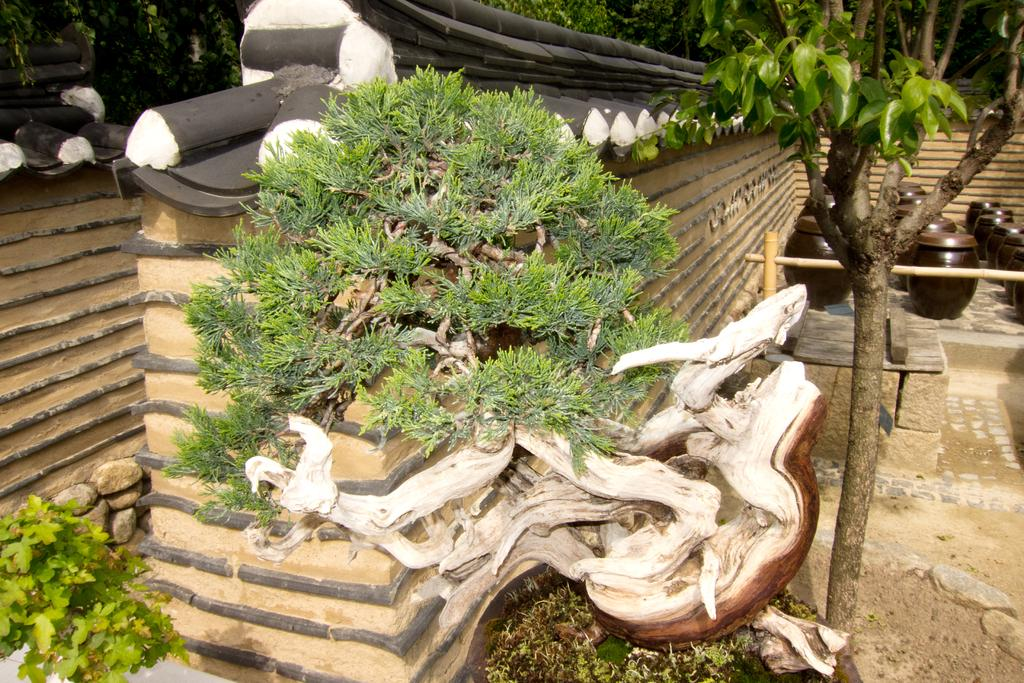What is on the wall in the image? There are plants on the wall in the image. What can be seen on the right side of the image? There are pots and a tree on the right side of the image. How many times do the plants on the wall hate each other in the image? There is no indication of emotions or interactions between the plants in the image, so it is not possible to answer that question. 